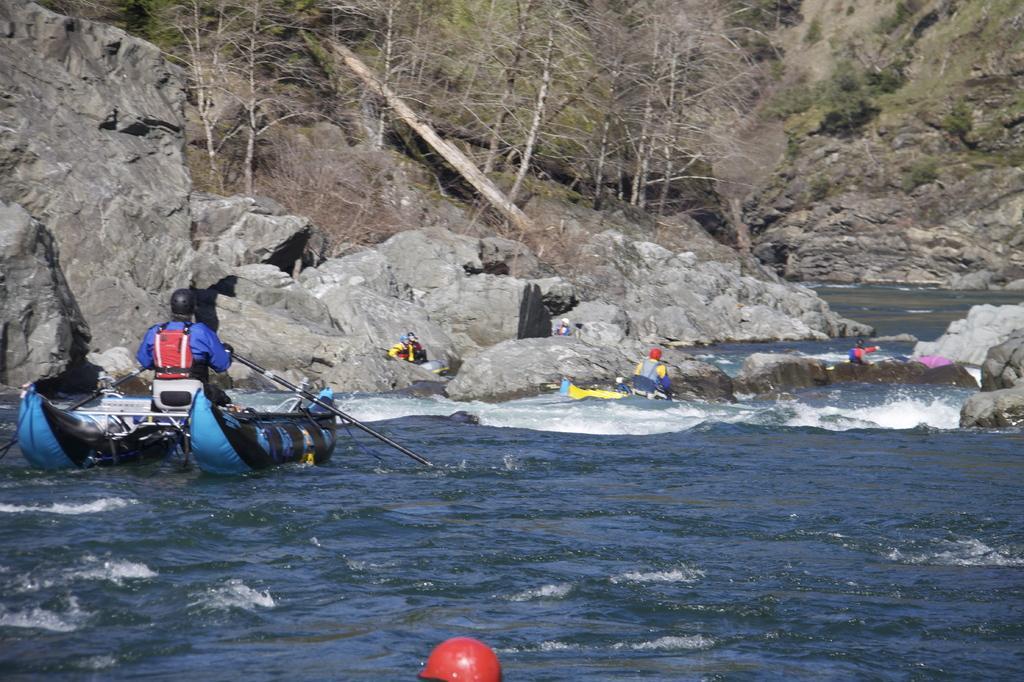Describe this image in one or two sentences. In this image we can see water body on which people are boating. Left side of the image mountains are there and trees are present. 